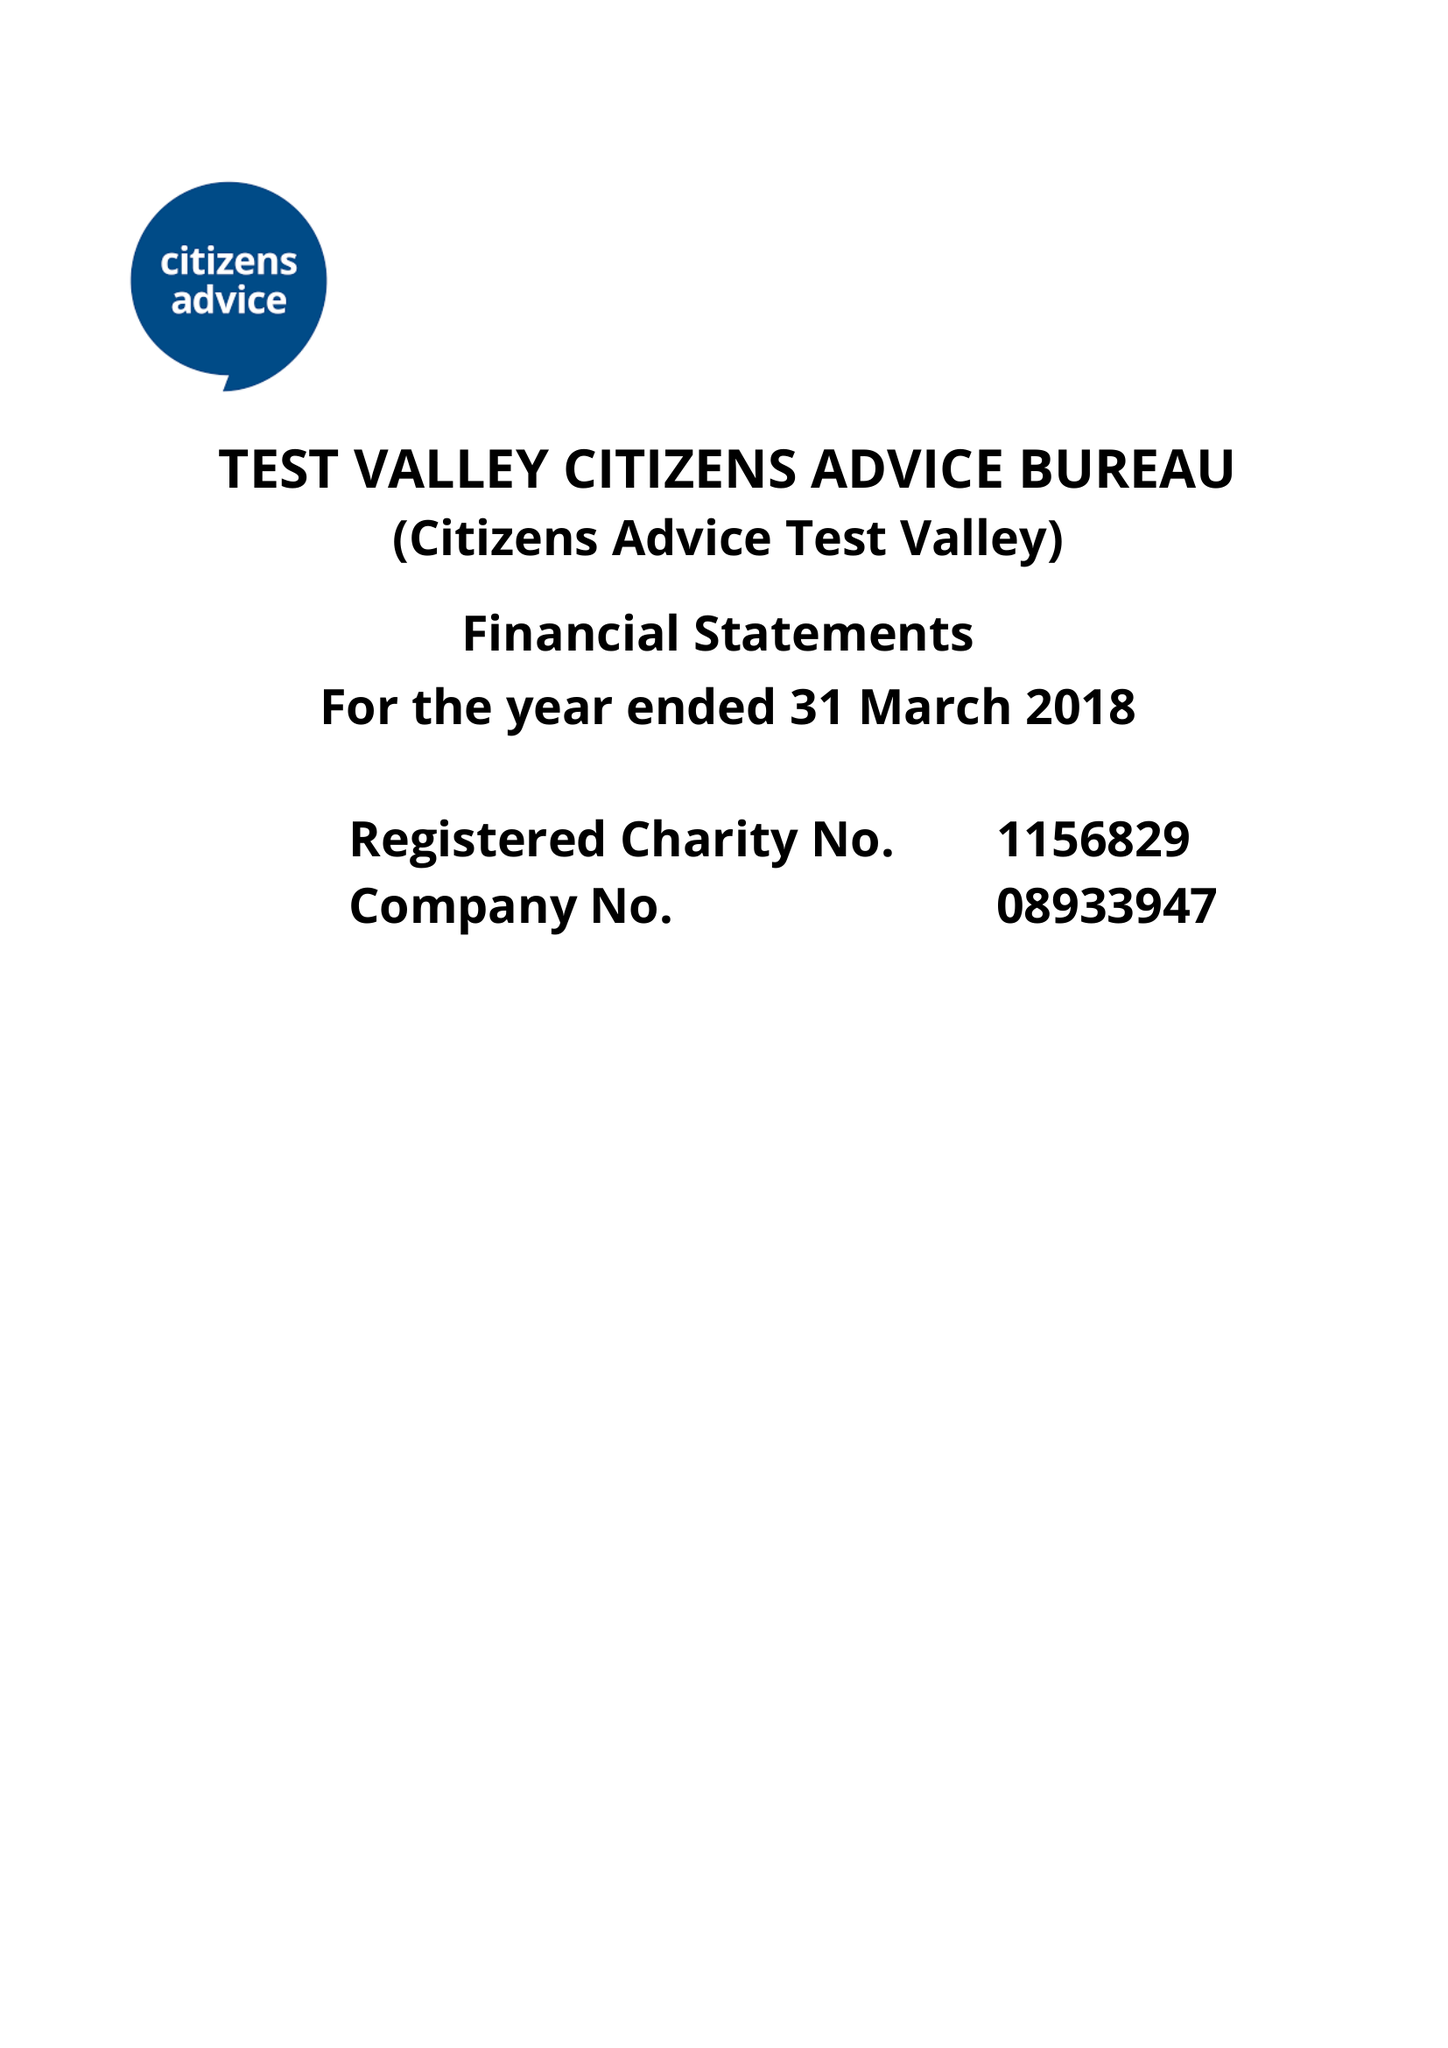What is the value for the address__street_line?
Answer the question using a single word or phrase. 35 LONDON STREET 